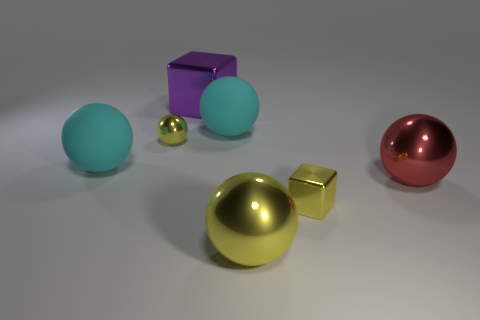How big is the yellow shiny ball in front of the big metal object right of the cube that is in front of the big red sphere?
Give a very brief answer. Large. Is the small metal sphere the same color as the large cube?
Ensure brevity in your answer.  No. There is a purple shiny object; what number of yellow spheres are to the right of it?
Offer a terse response. 1. Are there an equal number of things right of the red object and metal balls?
Your response must be concise. No. How many objects are either big matte things or big blue cylinders?
Your answer should be compact. 2. Is there anything else that is the same shape as the big purple thing?
Ensure brevity in your answer.  Yes. What is the shape of the large object left of the large block that is left of the tiny cube?
Offer a very short reply. Sphere. The red thing that is made of the same material as the big yellow thing is what shape?
Your response must be concise. Sphere. What is the size of the yellow metal thing that is to the left of the big cube behind the small metal sphere?
Offer a very short reply. Small. The purple shiny thing is what shape?
Provide a short and direct response. Cube. 